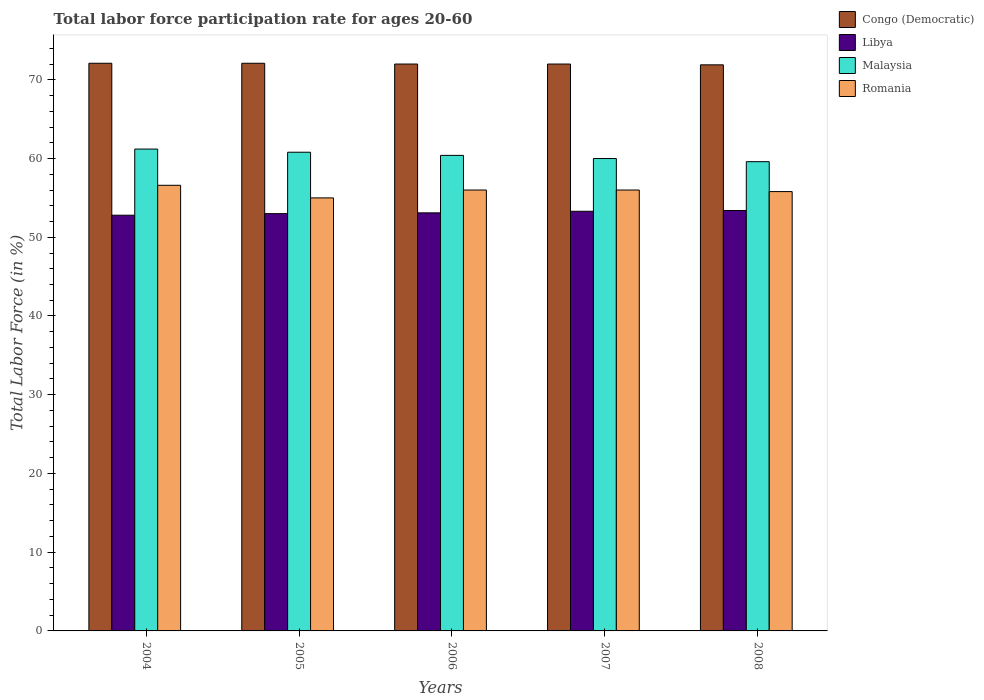How many different coloured bars are there?
Offer a terse response. 4. How many groups of bars are there?
Give a very brief answer. 5. Are the number of bars per tick equal to the number of legend labels?
Provide a short and direct response. Yes. Are the number of bars on each tick of the X-axis equal?
Ensure brevity in your answer.  Yes. How many bars are there on the 2nd tick from the left?
Ensure brevity in your answer.  4. How many bars are there on the 4th tick from the right?
Your answer should be compact. 4. What is the label of the 2nd group of bars from the left?
Give a very brief answer. 2005. In how many cases, is the number of bars for a given year not equal to the number of legend labels?
Provide a short and direct response. 0. What is the labor force participation rate in Congo (Democratic) in 2004?
Offer a very short reply. 72.1. Across all years, what is the maximum labor force participation rate in Congo (Democratic)?
Offer a very short reply. 72.1. Across all years, what is the minimum labor force participation rate in Romania?
Your answer should be compact. 55. In which year was the labor force participation rate in Congo (Democratic) maximum?
Provide a short and direct response. 2004. In which year was the labor force participation rate in Libya minimum?
Your answer should be very brief. 2004. What is the total labor force participation rate in Congo (Democratic) in the graph?
Give a very brief answer. 360.1. What is the difference between the labor force participation rate in Libya in 2004 and that in 2007?
Offer a terse response. -0.5. What is the difference between the labor force participation rate in Libya in 2008 and the labor force participation rate in Romania in 2005?
Give a very brief answer. -1.6. What is the average labor force participation rate in Congo (Democratic) per year?
Your response must be concise. 72.02. In the year 2007, what is the difference between the labor force participation rate in Libya and labor force participation rate in Malaysia?
Make the answer very short. -6.7. What is the ratio of the labor force participation rate in Libya in 2005 to that in 2007?
Your answer should be compact. 0.99. Is the labor force participation rate in Malaysia in 2004 less than that in 2007?
Offer a terse response. No. Is the difference between the labor force participation rate in Libya in 2005 and 2007 greater than the difference between the labor force participation rate in Malaysia in 2005 and 2007?
Offer a terse response. No. What is the difference between the highest and the second highest labor force participation rate in Libya?
Ensure brevity in your answer.  0.1. What is the difference between the highest and the lowest labor force participation rate in Malaysia?
Provide a succinct answer. 1.6. In how many years, is the labor force participation rate in Malaysia greater than the average labor force participation rate in Malaysia taken over all years?
Provide a short and direct response. 3. Is the sum of the labor force participation rate in Romania in 2004 and 2006 greater than the maximum labor force participation rate in Malaysia across all years?
Offer a very short reply. Yes. What does the 1st bar from the left in 2007 represents?
Offer a terse response. Congo (Democratic). What does the 4th bar from the right in 2005 represents?
Your answer should be compact. Congo (Democratic). Are the values on the major ticks of Y-axis written in scientific E-notation?
Provide a succinct answer. No. Where does the legend appear in the graph?
Give a very brief answer. Top right. How are the legend labels stacked?
Provide a short and direct response. Vertical. What is the title of the graph?
Keep it short and to the point. Total labor force participation rate for ages 20-60. What is the label or title of the X-axis?
Your answer should be very brief. Years. What is the label or title of the Y-axis?
Your answer should be very brief. Total Labor Force (in %). What is the Total Labor Force (in %) of Congo (Democratic) in 2004?
Give a very brief answer. 72.1. What is the Total Labor Force (in %) of Libya in 2004?
Give a very brief answer. 52.8. What is the Total Labor Force (in %) in Malaysia in 2004?
Make the answer very short. 61.2. What is the Total Labor Force (in %) in Romania in 2004?
Ensure brevity in your answer.  56.6. What is the Total Labor Force (in %) of Congo (Democratic) in 2005?
Keep it short and to the point. 72.1. What is the Total Labor Force (in %) in Malaysia in 2005?
Provide a succinct answer. 60.8. What is the Total Labor Force (in %) of Romania in 2005?
Offer a very short reply. 55. What is the Total Labor Force (in %) of Libya in 2006?
Your response must be concise. 53.1. What is the Total Labor Force (in %) in Malaysia in 2006?
Keep it short and to the point. 60.4. What is the Total Labor Force (in %) in Romania in 2006?
Keep it short and to the point. 56. What is the Total Labor Force (in %) of Libya in 2007?
Offer a terse response. 53.3. What is the Total Labor Force (in %) in Romania in 2007?
Your response must be concise. 56. What is the Total Labor Force (in %) of Congo (Democratic) in 2008?
Offer a terse response. 71.9. What is the Total Labor Force (in %) of Libya in 2008?
Your response must be concise. 53.4. What is the Total Labor Force (in %) of Malaysia in 2008?
Provide a succinct answer. 59.6. What is the Total Labor Force (in %) of Romania in 2008?
Provide a short and direct response. 55.8. Across all years, what is the maximum Total Labor Force (in %) of Congo (Democratic)?
Keep it short and to the point. 72.1. Across all years, what is the maximum Total Labor Force (in %) in Libya?
Ensure brevity in your answer.  53.4. Across all years, what is the maximum Total Labor Force (in %) in Malaysia?
Offer a very short reply. 61.2. Across all years, what is the maximum Total Labor Force (in %) in Romania?
Provide a short and direct response. 56.6. Across all years, what is the minimum Total Labor Force (in %) in Congo (Democratic)?
Offer a terse response. 71.9. Across all years, what is the minimum Total Labor Force (in %) of Libya?
Provide a succinct answer. 52.8. Across all years, what is the minimum Total Labor Force (in %) of Malaysia?
Provide a short and direct response. 59.6. What is the total Total Labor Force (in %) of Congo (Democratic) in the graph?
Keep it short and to the point. 360.1. What is the total Total Labor Force (in %) of Libya in the graph?
Keep it short and to the point. 265.6. What is the total Total Labor Force (in %) in Malaysia in the graph?
Your response must be concise. 302. What is the total Total Labor Force (in %) in Romania in the graph?
Provide a succinct answer. 279.4. What is the difference between the Total Labor Force (in %) in Congo (Democratic) in 2004 and that in 2005?
Offer a very short reply. 0. What is the difference between the Total Labor Force (in %) of Congo (Democratic) in 2004 and that in 2006?
Your response must be concise. 0.1. What is the difference between the Total Labor Force (in %) of Libya in 2004 and that in 2006?
Ensure brevity in your answer.  -0.3. What is the difference between the Total Labor Force (in %) in Romania in 2004 and that in 2006?
Keep it short and to the point. 0.6. What is the difference between the Total Labor Force (in %) of Congo (Democratic) in 2004 and that in 2007?
Your response must be concise. 0.1. What is the difference between the Total Labor Force (in %) in Malaysia in 2004 and that in 2007?
Provide a succinct answer. 1.2. What is the difference between the Total Labor Force (in %) in Congo (Democratic) in 2005 and that in 2006?
Make the answer very short. 0.1. What is the difference between the Total Labor Force (in %) in Malaysia in 2005 and that in 2006?
Offer a terse response. 0.4. What is the difference between the Total Labor Force (in %) in Congo (Democratic) in 2005 and that in 2007?
Your response must be concise. 0.1. What is the difference between the Total Labor Force (in %) of Congo (Democratic) in 2005 and that in 2008?
Your answer should be very brief. 0.2. What is the difference between the Total Labor Force (in %) of Libya in 2006 and that in 2007?
Your answer should be compact. -0.2. What is the difference between the Total Labor Force (in %) in Congo (Democratic) in 2006 and that in 2008?
Provide a succinct answer. 0.1. What is the difference between the Total Labor Force (in %) in Libya in 2006 and that in 2008?
Keep it short and to the point. -0.3. What is the difference between the Total Labor Force (in %) in Malaysia in 2006 and that in 2008?
Provide a succinct answer. 0.8. What is the difference between the Total Labor Force (in %) in Romania in 2006 and that in 2008?
Your response must be concise. 0.2. What is the difference between the Total Labor Force (in %) in Congo (Democratic) in 2007 and that in 2008?
Provide a succinct answer. 0.1. What is the difference between the Total Labor Force (in %) of Romania in 2007 and that in 2008?
Provide a short and direct response. 0.2. What is the difference between the Total Labor Force (in %) in Congo (Democratic) in 2004 and the Total Labor Force (in %) in Malaysia in 2005?
Offer a terse response. 11.3. What is the difference between the Total Labor Force (in %) in Congo (Democratic) in 2004 and the Total Labor Force (in %) in Romania in 2005?
Provide a short and direct response. 17.1. What is the difference between the Total Labor Force (in %) of Libya in 2004 and the Total Labor Force (in %) of Malaysia in 2005?
Your answer should be compact. -8. What is the difference between the Total Labor Force (in %) of Libya in 2004 and the Total Labor Force (in %) of Romania in 2005?
Provide a short and direct response. -2.2. What is the difference between the Total Labor Force (in %) of Malaysia in 2004 and the Total Labor Force (in %) of Romania in 2005?
Your answer should be compact. 6.2. What is the difference between the Total Labor Force (in %) in Congo (Democratic) in 2004 and the Total Labor Force (in %) in Libya in 2006?
Give a very brief answer. 19. What is the difference between the Total Labor Force (in %) of Congo (Democratic) in 2004 and the Total Labor Force (in %) of Romania in 2006?
Ensure brevity in your answer.  16.1. What is the difference between the Total Labor Force (in %) in Malaysia in 2004 and the Total Labor Force (in %) in Romania in 2006?
Provide a short and direct response. 5.2. What is the difference between the Total Labor Force (in %) in Congo (Democratic) in 2004 and the Total Labor Force (in %) in Libya in 2007?
Ensure brevity in your answer.  18.8. What is the difference between the Total Labor Force (in %) of Congo (Democratic) in 2004 and the Total Labor Force (in %) of Romania in 2007?
Ensure brevity in your answer.  16.1. What is the difference between the Total Labor Force (in %) in Libya in 2004 and the Total Labor Force (in %) in Malaysia in 2007?
Give a very brief answer. -7.2. What is the difference between the Total Labor Force (in %) of Libya in 2004 and the Total Labor Force (in %) of Romania in 2007?
Provide a short and direct response. -3.2. What is the difference between the Total Labor Force (in %) in Congo (Democratic) in 2004 and the Total Labor Force (in %) in Romania in 2008?
Offer a terse response. 16.3. What is the difference between the Total Labor Force (in %) of Libya in 2004 and the Total Labor Force (in %) of Malaysia in 2008?
Offer a terse response. -6.8. What is the difference between the Total Labor Force (in %) of Malaysia in 2004 and the Total Labor Force (in %) of Romania in 2008?
Your response must be concise. 5.4. What is the difference between the Total Labor Force (in %) of Congo (Democratic) in 2005 and the Total Labor Force (in %) of Libya in 2006?
Make the answer very short. 19. What is the difference between the Total Labor Force (in %) in Congo (Democratic) in 2005 and the Total Labor Force (in %) in Malaysia in 2006?
Keep it short and to the point. 11.7. What is the difference between the Total Labor Force (in %) in Congo (Democratic) in 2005 and the Total Labor Force (in %) in Romania in 2006?
Keep it short and to the point. 16.1. What is the difference between the Total Labor Force (in %) of Libya in 2005 and the Total Labor Force (in %) of Malaysia in 2006?
Your answer should be very brief. -7.4. What is the difference between the Total Labor Force (in %) in Malaysia in 2005 and the Total Labor Force (in %) in Romania in 2006?
Your answer should be very brief. 4.8. What is the difference between the Total Labor Force (in %) in Congo (Democratic) in 2005 and the Total Labor Force (in %) in Libya in 2007?
Ensure brevity in your answer.  18.8. What is the difference between the Total Labor Force (in %) of Congo (Democratic) in 2005 and the Total Labor Force (in %) of Romania in 2007?
Give a very brief answer. 16.1. What is the difference between the Total Labor Force (in %) in Libya in 2005 and the Total Labor Force (in %) in Malaysia in 2007?
Give a very brief answer. -7. What is the difference between the Total Labor Force (in %) in Libya in 2005 and the Total Labor Force (in %) in Romania in 2007?
Provide a succinct answer. -3. What is the difference between the Total Labor Force (in %) in Congo (Democratic) in 2005 and the Total Labor Force (in %) in Libya in 2008?
Offer a very short reply. 18.7. What is the difference between the Total Labor Force (in %) of Congo (Democratic) in 2005 and the Total Labor Force (in %) of Malaysia in 2008?
Provide a short and direct response. 12.5. What is the difference between the Total Labor Force (in %) in Libya in 2005 and the Total Labor Force (in %) in Romania in 2008?
Ensure brevity in your answer.  -2.8. What is the difference between the Total Labor Force (in %) of Malaysia in 2005 and the Total Labor Force (in %) of Romania in 2008?
Keep it short and to the point. 5. What is the difference between the Total Labor Force (in %) of Libya in 2006 and the Total Labor Force (in %) of Romania in 2007?
Provide a succinct answer. -2.9. What is the difference between the Total Labor Force (in %) in Malaysia in 2006 and the Total Labor Force (in %) in Romania in 2007?
Offer a very short reply. 4.4. What is the difference between the Total Labor Force (in %) in Congo (Democratic) in 2006 and the Total Labor Force (in %) in Romania in 2008?
Provide a succinct answer. 16.2. What is the difference between the Total Labor Force (in %) of Libya in 2006 and the Total Labor Force (in %) of Malaysia in 2008?
Provide a succinct answer. -6.5. What is the difference between the Total Labor Force (in %) in Congo (Democratic) in 2007 and the Total Labor Force (in %) in Libya in 2008?
Keep it short and to the point. 18.6. What is the difference between the Total Labor Force (in %) of Congo (Democratic) in 2007 and the Total Labor Force (in %) of Romania in 2008?
Give a very brief answer. 16.2. What is the difference between the Total Labor Force (in %) of Libya in 2007 and the Total Labor Force (in %) of Malaysia in 2008?
Keep it short and to the point. -6.3. What is the difference between the Total Labor Force (in %) in Libya in 2007 and the Total Labor Force (in %) in Romania in 2008?
Keep it short and to the point. -2.5. What is the difference between the Total Labor Force (in %) in Malaysia in 2007 and the Total Labor Force (in %) in Romania in 2008?
Offer a very short reply. 4.2. What is the average Total Labor Force (in %) in Congo (Democratic) per year?
Ensure brevity in your answer.  72.02. What is the average Total Labor Force (in %) of Libya per year?
Your answer should be very brief. 53.12. What is the average Total Labor Force (in %) of Malaysia per year?
Your answer should be compact. 60.4. What is the average Total Labor Force (in %) of Romania per year?
Ensure brevity in your answer.  55.88. In the year 2004, what is the difference between the Total Labor Force (in %) in Congo (Democratic) and Total Labor Force (in %) in Libya?
Your response must be concise. 19.3. In the year 2004, what is the difference between the Total Labor Force (in %) of Congo (Democratic) and Total Labor Force (in %) of Romania?
Offer a very short reply. 15.5. In the year 2004, what is the difference between the Total Labor Force (in %) of Malaysia and Total Labor Force (in %) of Romania?
Your response must be concise. 4.6. In the year 2005, what is the difference between the Total Labor Force (in %) in Congo (Democratic) and Total Labor Force (in %) in Libya?
Provide a short and direct response. 19.1. In the year 2005, what is the difference between the Total Labor Force (in %) in Malaysia and Total Labor Force (in %) in Romania?
Your response must be concise. 5.8. In the year 2006, what is the difference between the Total Labor Force (in %) in Congo (Democratic) and Total Labor Force (in %) in Malaysia?
Offer a terse response. 11.6. In the year 2006, what is the difference between the Total Labor Force (in %) of Libya and Total Labor Force (in %) of Malaysia?
Keep it short and to the point. -7.3. In the year 2006, what is the difference between the Total Labor Force (in %) in Malaysia and Total Labor Force (in %) in Romania?
Keep it short and to the point. 4.4. In the year 2007, what is the difference between the Total Labor Force (in %) in Congo (Democratic) and Total Labor Force (in %) in Libya?
Offer a very short reply. 18.7. In the year 2007, what is the difference between the Total Labor Force (in %) of Congo (Democratic) and Total Labor Force (in %) of Romania?
Offer a very short reply. 16. In the year 2007, what is the difference between the Total Labor Force (in %) in Libya and Total Labor Force (in %) in Malaysia?
Your answer should be compact. -6.7. In the year 2007, what is the difference between the Total Labor Force (in %) in Libya and Total Labor Force (in %) in Romania?
Ensure brevity in your answer.  -2.7. In the year 2008, what is the difference between the Total Labor Force (in %) in Congo (Democratic) and Total Labor Force (in %) in Libya?
Keep it short and to the point. 18.5. In the year 2008, what is the difference between the Total Labor Force (in %) of Congo (Democratic) and Total Labor Force (in %) of Malaysia?
Offer a terse response. 12.3. In the year 2008, what is the difference between the Total Labor Force (in %) of Congo (Democratic) and Total Labor Force (in %) of Romania?
Ensure brevity in your answer.  16.1. In the year 2008, what is the difference between the Total Labor Force (in %) of Libya and Total Labor Force (in %) of Malaysia?
Ensure brevity in your answer.  -6.2. In the year 2008, what is the difference between the Total Labor Force (in %) in Libya and Total Labor Force (in %) in Romania?
Offer a terse response. -2.4. In the year 2008, what is the difference between the Total Labor Force (in %) of Malaysia and Total Labor Force (in %) of Romania?
Make the answer very short. 3.8. What is the ratio of the Total Labor Force (in %) of Congo (Democratic) in 2004 to that in 2005?
Offer a very short reply. 1. What is the ratio of the Total Labor Force (in %) in Malaysia in 2004 to that in 2005?
Ensure brevity in your answer.  1.01. What is the ratio of the Total Labor Force (in %) of Romania in 2004 to that in 2005?
Provide a short and direct response. 1.03. What is the ratio of the Total Labor Force (in %) of Malaysia in 2004 to that in 2006?
Offer a terse response. 1.01. What is the ratio of the Total Labor Force (in %) of Romania in 2004 to that in 2006?
Your answer should be very brief. 1.01. What is the ratio of the Total Labor Force (in %) in Congo (Democratic) in 2004 to that in 2007?
Provide a succinct answer. 1. What is the ratio of the Total Labor Force (in %) of Libya in 2004 to that in 2007?
Your answer should be compact. 0.99. What is the ratio of the Total Labor Force (in %) in Romania in 2004 to that in 2007?
Provide a short and direct response. 1.01. What is the ratio of the Total Labor Force (in %) in Malaysia in 2004 to that in 2008?
Offer a very short reply. 1.03. What is the ratio of the Total Labor Force (in %) in Romania in 2004 to that in 2008?
Keep it short and to the point. 1.01. What is the ratio of the Total Labor Force (in %) of Congo (Democratic) in 2005 to that in 2006?
Ensure brevity in your answer.  1. What is the ratio of the Total Labor Force (in %) in Malaysia in 2005 to that in 2006?
Keep it short and to the point. 1.01. What is the ratio of the Total Labor Force (in %) of Romania in 2005 to that in 2006?
Keep it short and to the point. 0.98. What is the ratio of the Total Labor Force (in %) in Congo (Democratic) in 2005 to that in 2007?
Your response must be concise. 1. What is the ratio of the Total Labor Force (in %) of Malaysia in 2005 to that in 2007?
Offer a terse response. 1.01. What is the ratio of the Total Labor Force (in %) in Romania in 2005 to that in 2007?
Your answer should be very brief. 0.98. What is the ratio of the Total Labor Force (in %) of Malaysia in 2005 to that in 2008?
Give a very brief answer. 1.02. What is the ratio of the Total Labor Force (in %) in Romania in 2005 to that in 2008?
Offer a very short reply. 0.99. What is the ratio of the Total Labor Force (in %) of Malaysia in 2006 to that in 2007?
Ensure brevity in your answer.  1.01. What is the ratio of the Total Labor Force (in %) in Congo (Democratic) in 2006 to that in 2008?
Give a very brief answer. 1. What is the ratio of the Total Labor Force (in %) of Libya in 2006 to that in 2008?
Your answer should be very brief. 0.99. What is the ratio of the Total Labor Force (in %) of Malaysia in 2006 to that in 2008?
Your answer should be compact. 1.01. What is the ratio of the Total Labor Force (in %) in Libya in 2007 to that in 2008?
Ensure brevity in your answer.  1. What is the ratio of the Total Labor Force (in %) in Malaysia in 2007 to that in 2008?
Ensure brevity in your answer.  1.01. What is the difference between the highest and the second highest Total Labor Force (in %) in Congo (Democratic)?
Offer a very short reply. 0. What is the difference between the highest and the second highest Total Labor Force (in %) in Libya?
Keep it short and to the point. 0.1. What is the difference between the highest and the lowest Total Labor Force (in %) in Libya?
Offer a very short reply. 0.6. What is the difference between the highest and the lowest Total Labor Force (in %) of Malaysia?
Keep it short and to the point. 1.6. 